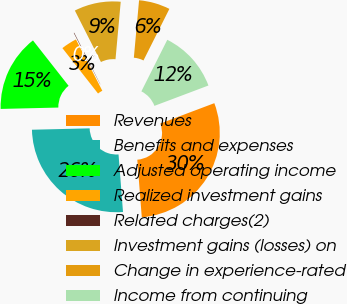<chart> <loc_0><loc_0><loc_500><loc_500><pie_chart><fcel>Revenues<fcel>Benefits and expenses<fcel>Adjusted operating income<fcel>Realized investment gains<fcel>Related charges(2)<fcel>Investment gains (losses) on<fcel>Change in experience-rated<fcel>Income from continuing<nl><fcel>29.5%<fcel>25.85%<fcel>14.79%<fcel>3.03%<fcel>0.09%<fcel>8.91%<fcel>5.97%<fcel>11.85%<nl></chart> 